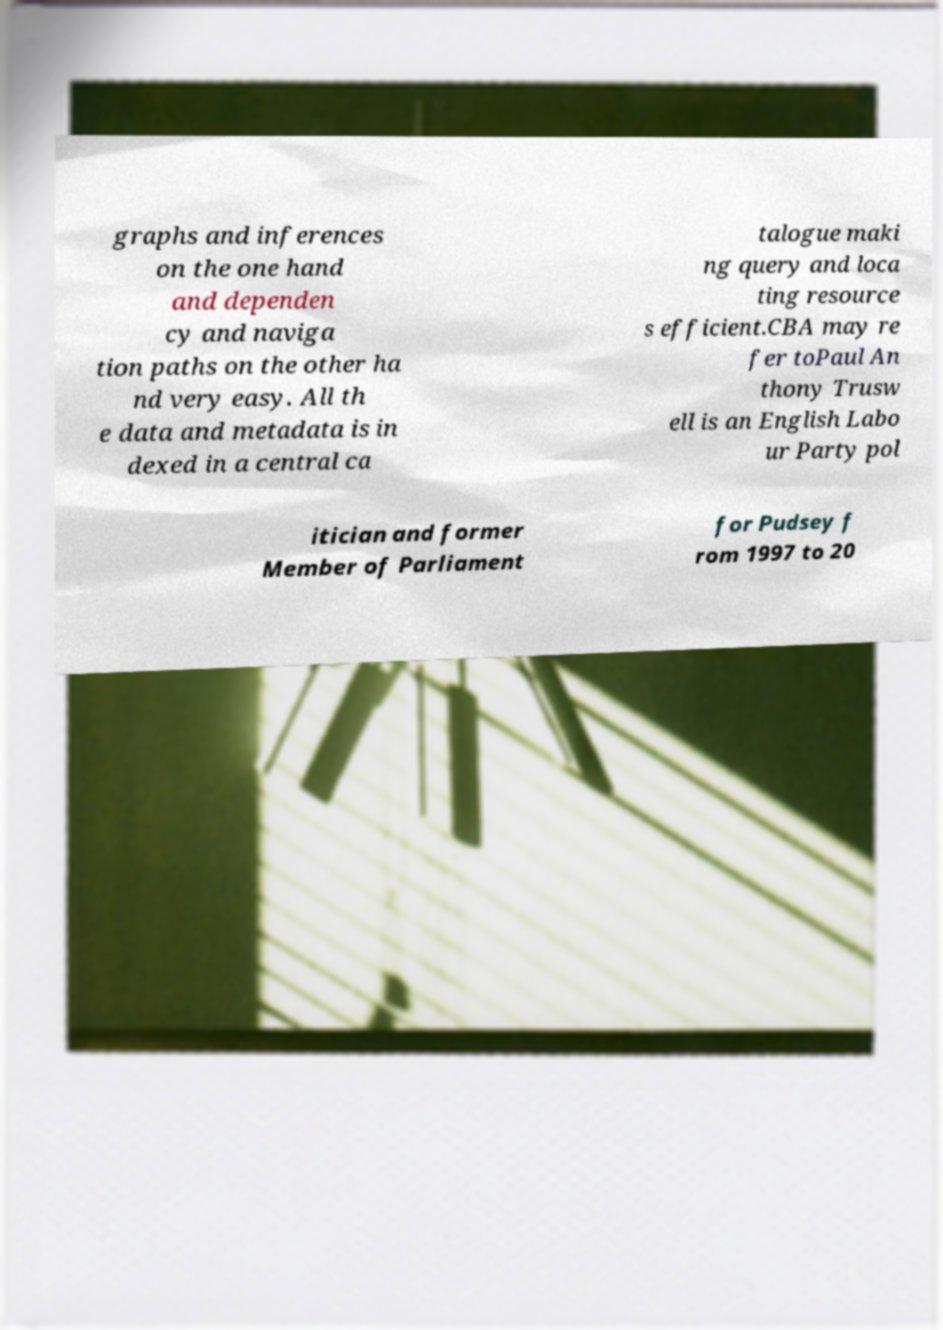Please identify and transcribe the text found in this image. graphs and inferences on the one hand and dependen cy and naviga tion paths on the other ha nd very easy. All th e data and metadata is in dexed in a central ca talogue maki ng query and loca ting resource s efficient.CBA may re fer toPaul An thony Trusw ell is an English Labo ur Party pol itician and former Member of Parliament for Pudsey f rom 1997 to 20 